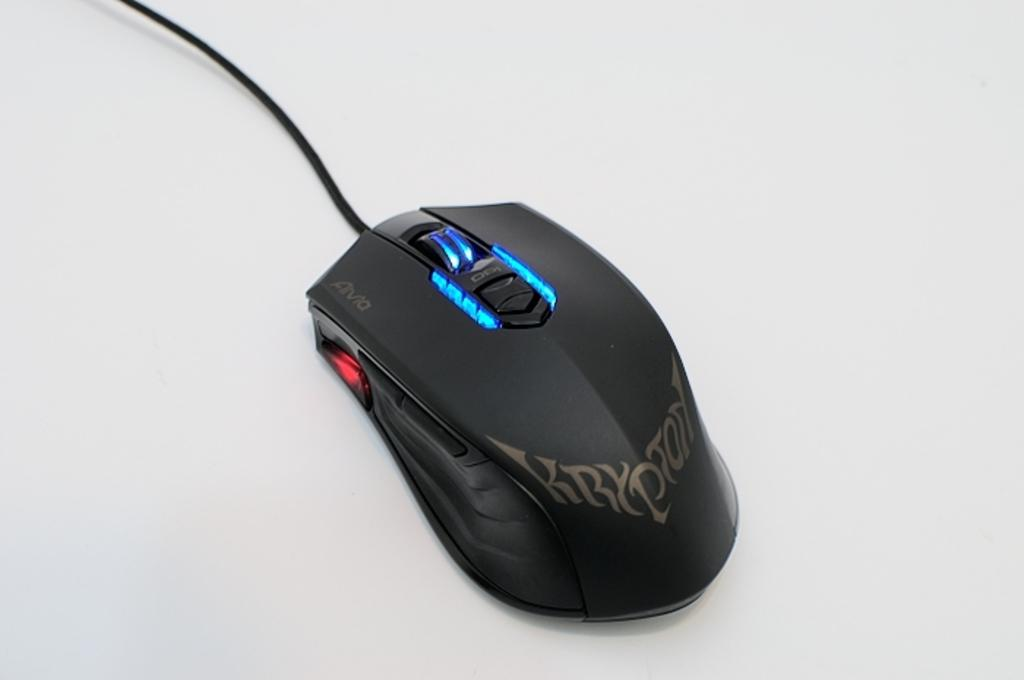Provide a one-sentence caption for the provided image. A black Krypton mouse is sitting on a gray surface. 